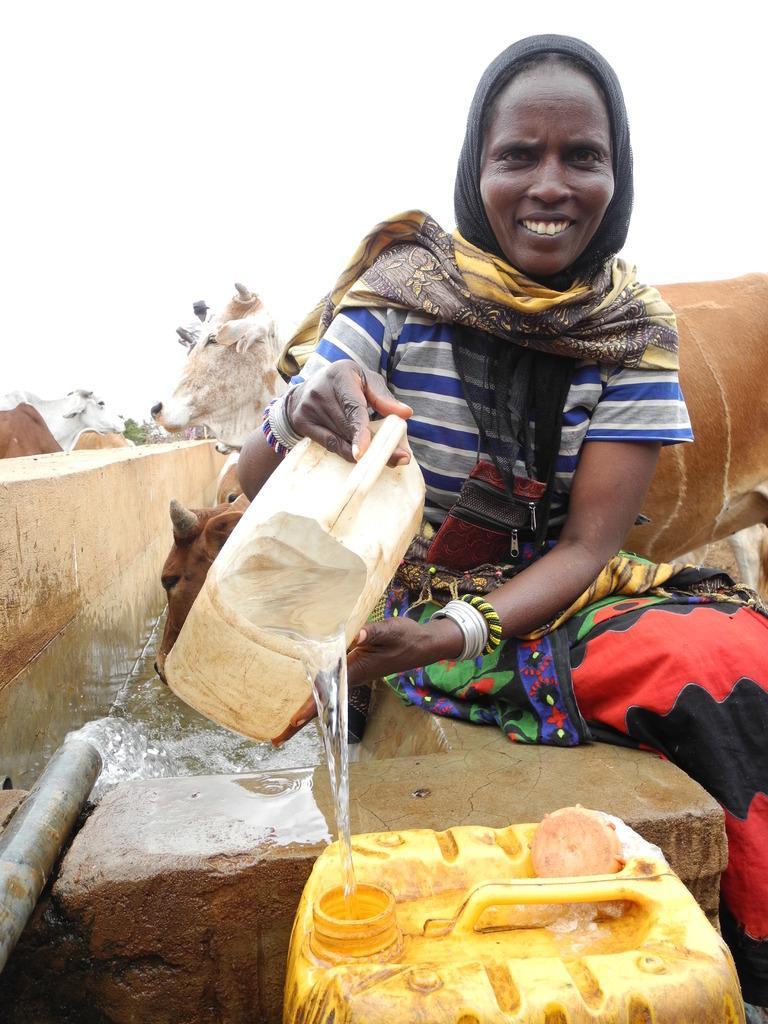Can you describe this image briefly? In the center of the image we can see a lady sitting and holding a container containing water. At the bottom there is a drum. On the left there is a pipe and we can see water. In the background there are cows and we can see a wall. At the top there is sky. 